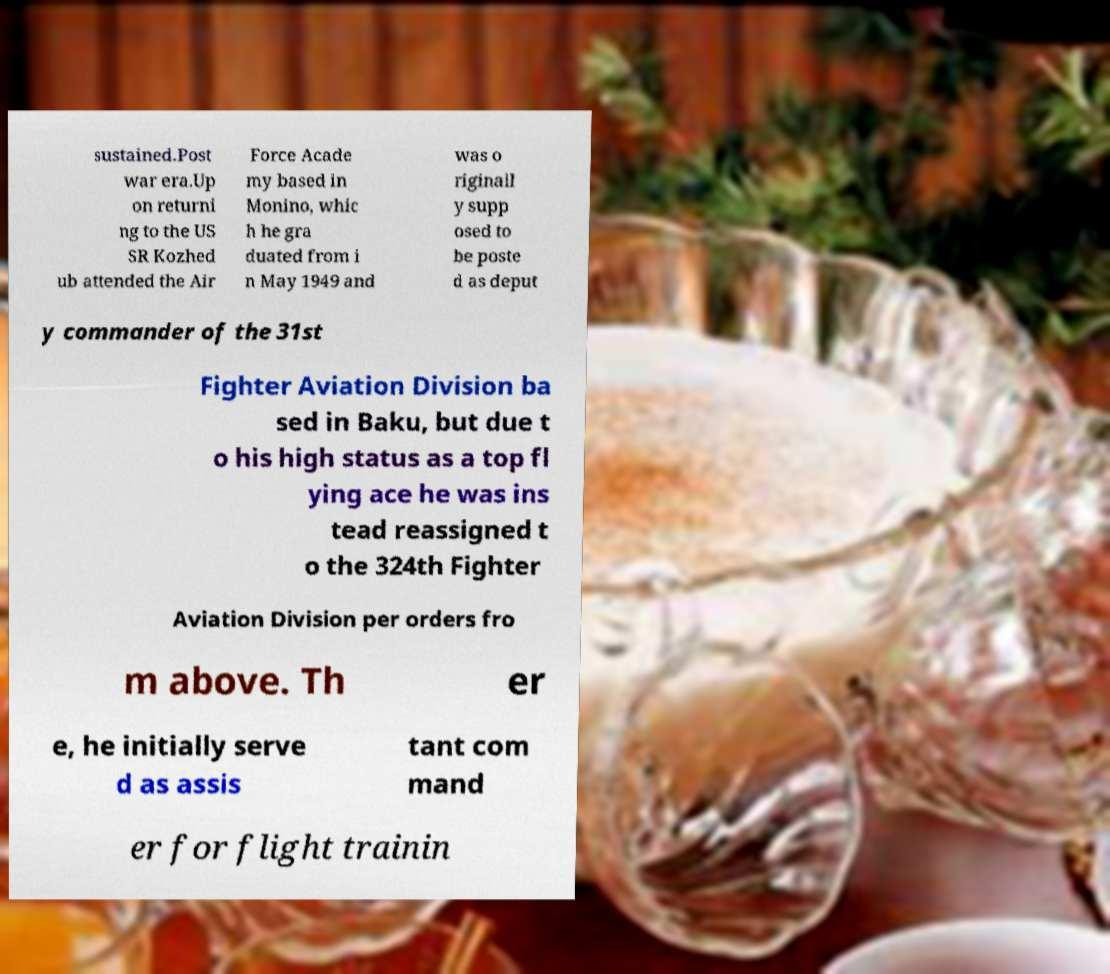Please read and relay the text visible in this image. What does it say? sustained.Post war era.Up on returni ng to the US SR Kozhed ub attended the Air Force Acade my based in Monino, whic h he gra duated from i n May 1949 and was o riginall y supp osed to be poste d as deput y commander of the 31st Fighter Aviation Division ba sed in Baku, but due t o his high status as a top fl ying ace he was ins tead reassigned t o the 324th Fighter Aviation Division per orders fro m above. Th er e, he initially serve d as assis tant com mand er for flight trainin 